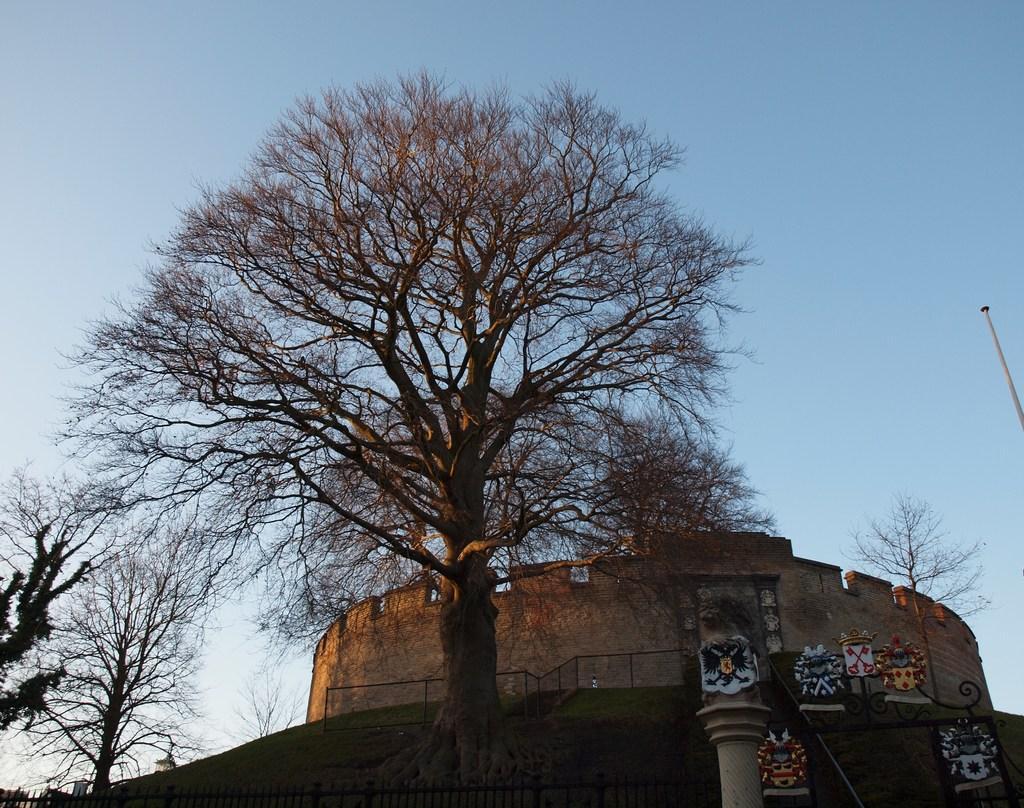Can you describe this image briefly? In the foreground, we can see trees and a monument. The sky is in the background. 